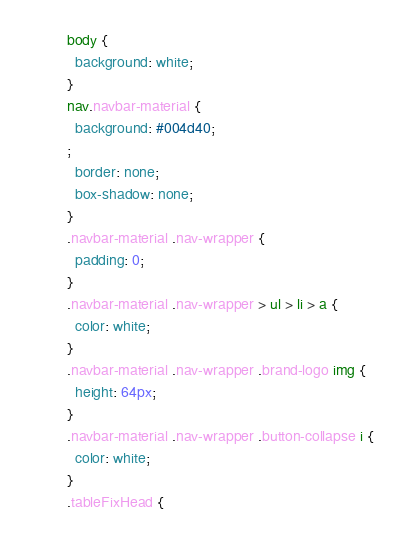<code> <loc_0><loc_0><loc_500><loc_500><_CSS_>body {
  background: white;
}
nav.navbar-material {
  background: #004d40;
;
  border: none;
  box-shadow: none;
}
.navbar-material .nav-wrapper {
  padding: 0;
}
.navbar-material .nav-wrapper > ul > li > a {
  color: white;
}
.navbar-material .nav-wrapper .brand-logo img {
  height: 64px;
}
.navbar-material .nav-wrapper .button-collapse i {
  color: white;
}
.tableFixHead {</code> 